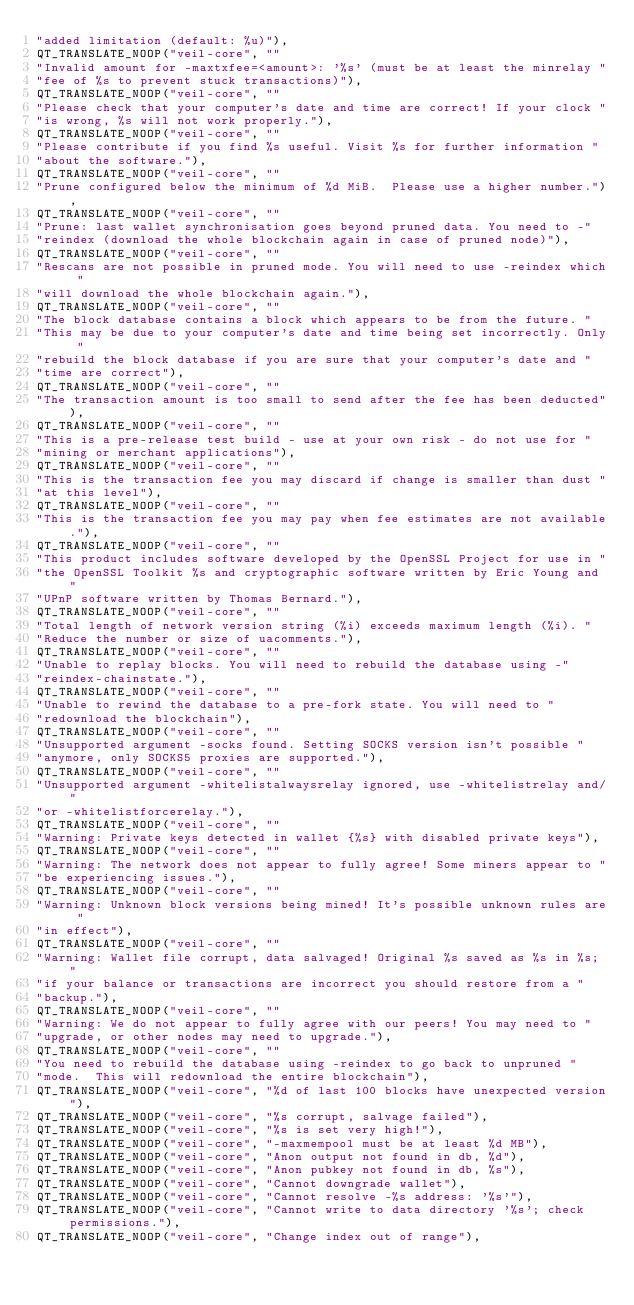Convert code to text. <code><loc_0><loc_0><loc_500><loc_500><_C++_>"added limitation (default: %u)"),
QT_TRANSLATE_NOOP("veil-core", ""
"Invalid amount for -maxtxfee=<amount>: '%s' (must be at least the minrelay "
"fee of %s to prevent stuck transactions)"),
QT_TRANSLATE_NOOP("veil-core", ""
"Please check that your computer's date and time are correct! If your clock "
"is wrong, %s will not work properly."),
QT_TRANSLATE_NOOP("veil-core", ""
"Please contribute if you find %s useful. Visit %s for further information "
"about the software."),
QT_TRANSLATE_NOOP("veil-core", ""
"Prune configured below the minimum of %d MiB.  Please use a higher number."),
QT_TRANSLATE_NOOP("veil-core", ""
"Prune: last wallet synchronisation goes beyond pruned data. You need to -"
"reindex (download the whole blockchain again in case of pruned node)"),
QT_TRANSLATE_NOOP("veil-core", ""
"Rescans are not possible in pruned mode. You will need to use -reindex which "
"will download the whole blockchain again."),
QT_TRANSLATE_NOOP("veil-core", ""
"The block database contains a block which appears to be from the future. "
"This may be due to your computer's date and time being set incorrectly. Only "
"rebuild the block database if you are sure that your computer's date and "
"time are correct"),
QT_TRANSLATE_NOOP("veil-core", ""
"The transaction amount is too small to send after the fee has been deducted"),
QT_TRANSLATE_NOOP("veil-core", ""
"This is a pre-release test build - use at your own risk - do not use for "
"mining or merchant applications"),
QT_TRANSLATE_NOOP("veil-core", ""
"This is the transaction fee you may discard if change is smaller than dust "
"at this level"),
QT_TRANSLATE_NOOP("veil-core", ""
"This is the transaction fee you may pay when fee estimates are not available."),
QT_TRANSLATE_NOOP("veil-core", ""
"This product includes software developed by the OpenSSL Project for use in "
"the OpenSSL Toolkit %s and cryptographic software written by Eric Young and "
"UPnP software written by Thomas Bernard."),
QT_TRANSLATE_NOOP("veil-core", ""
"Total length of network version string (%i) exceeds maximum length (%i). "
"Reduce the number or size of uacomments."),
QT_TRANSLATE_NOOP("veil-core", ""
"Unable to replay blocks. You will need to rebuild the database using -"
"reindex-chainstate."),
QT_TRANSLATE_NOOP("veil-core", ""
"Unable to rewind the database to a pre-fork state. You will need to "
"redownload the blockchain"),
QT_TRANSLATE_NOOP("veil-core", ""
"Unsupported argument -socks found. Setting SOCKS version isn't possible "
"anymore, only SOCKS5 proxies are supported."),
QT_TRANSLATE_NOOP("veil-core", ""
"Unsupported argument -whitelistalwaysrelay ignored, use -whitelistrelay and/"
"or -whitelistforcerelay."),
QT_TRANSLATE_NOOP("veil-core", ""
"Warning: Private keys detected in wallet {%s} with disabled private keys"),
QT_TRANSLATE_NOOP("veil-core", ""
"Warning: The network does not appear to fully agree! Some miners appear to "
"be experiencing issues."),
QT_TRANSLATE_NOOP("veil-core", ""
"Warning: Unknown block versions being mined! It's possible unknown rules are "
"in effect"),
QT_TRANSLATE_NOOP("veil-core", ""
"Warning: Wallet file corrupt, data salvaged! Original %s saved as %s in %s; "
"if your balance or transactions are incorrect you should restore from a "
"backup."),
QT_TRANSLATE_NOOP("veil-core", ""
"Warning: We do not appear to fully agree with our peers! You may need to "
"upgrade, or other nodes may need to upgrade."),
QT_TRANSLATE_NOOP("veil-core", ""
"You need to rebuild the database using -reindex to go back to unpruned "
"mode.  This will redownload the entire blockchain"),
QT_TRANSLATE_NOOP("veil-core", "%d of last 100 blocks have unexpected version"),
QT_TRANSLATE_NOOP("veil-core", "%s corrupt, salvage failed"),
QT_TRANSLATE_NOOP("veil-core", "%s is set very high!"),
QT_TRANSLATE_NOOP("veil-core", "-maxmempool must be at least %d MB"),
QT_TRANSLATE_NOOP("veil-core", "Anon output not found in db, %d"),
QT_TRANSLATE_NOOP("veil-core", "Anon pubkey not found in db, %s"),
QT_TRANSLATE_NOOP("veil-core", "Cannot downgrade wallet"),
QT_TRANSLATE_NOOP("veil-core", "Cannot resolve -%s address: '%s'"),
QT_TRANSLATE_NOOP("veil-core", "Cannot write to data directory '%s'; check permissions."),
QT_TRANSLATE_NOOP("veil-core", "Change index out of range"),</code> 